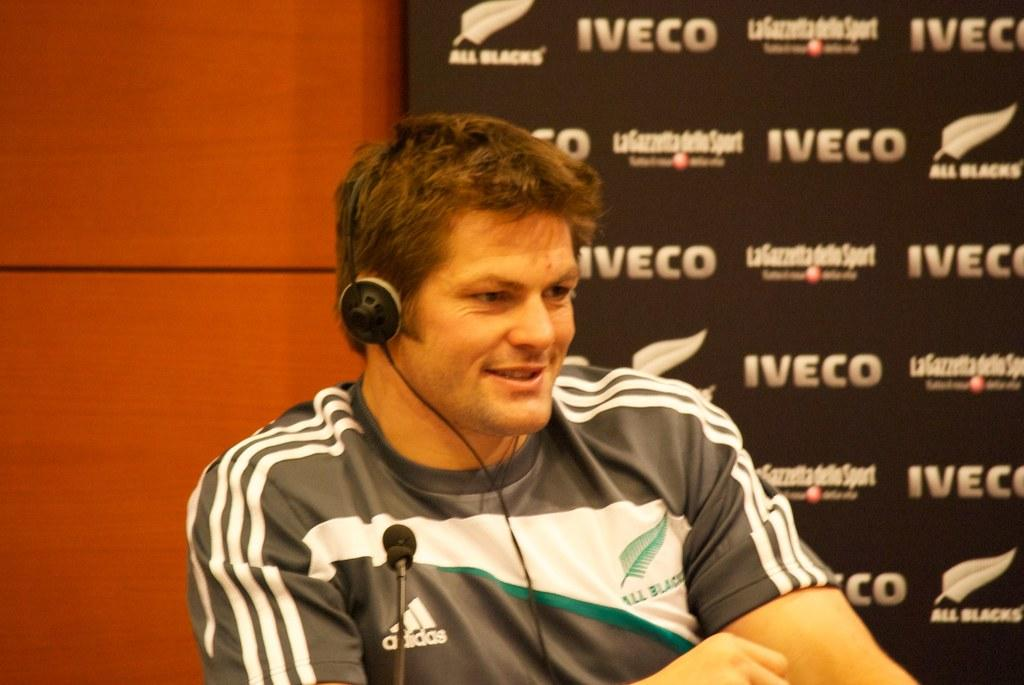<image>
Relay a brief, clear account of the picture shown. A man sits in front of a microphone at a table by a wall with Iveco All Blacks advertised. 